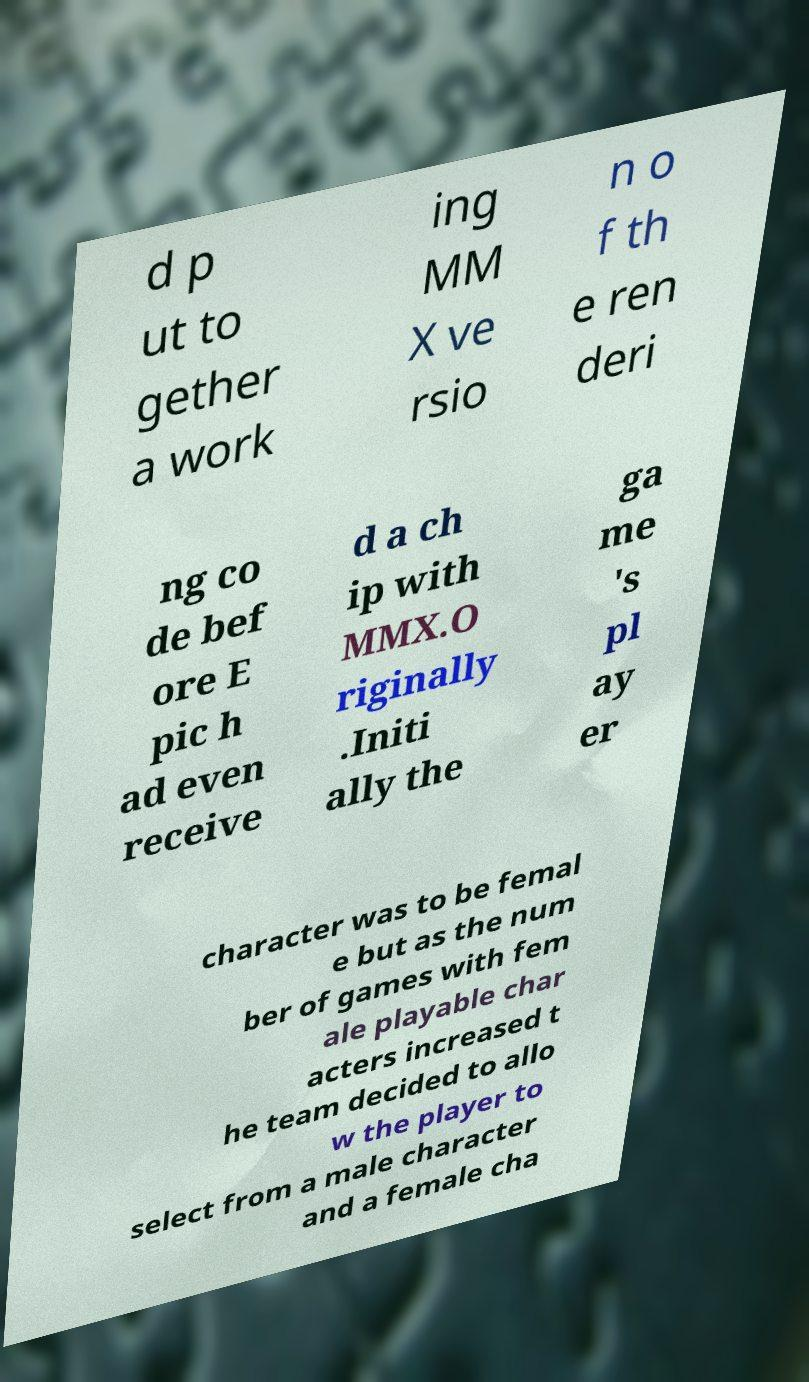There's text embedded in this image that I need extracted. Can you transcribe it verbatim? d p ut to gether a work ing MM X ve rsio n o f th e ren deri ng co de bef ore E pic h ad even receive d a ch ip with MMX.O riginally .Initi ally the ga me 's pl ay er character was to be femal e but as the num ber of games with fem ale playable char acters increased t he team decided to allo w the player to select from a male character and a female cha 